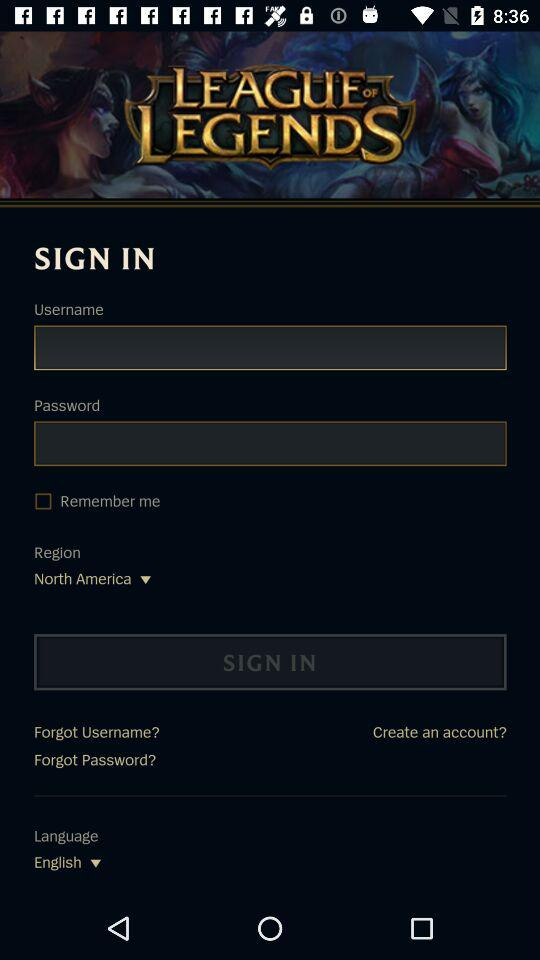Which region is selected? The selected region is North America. 